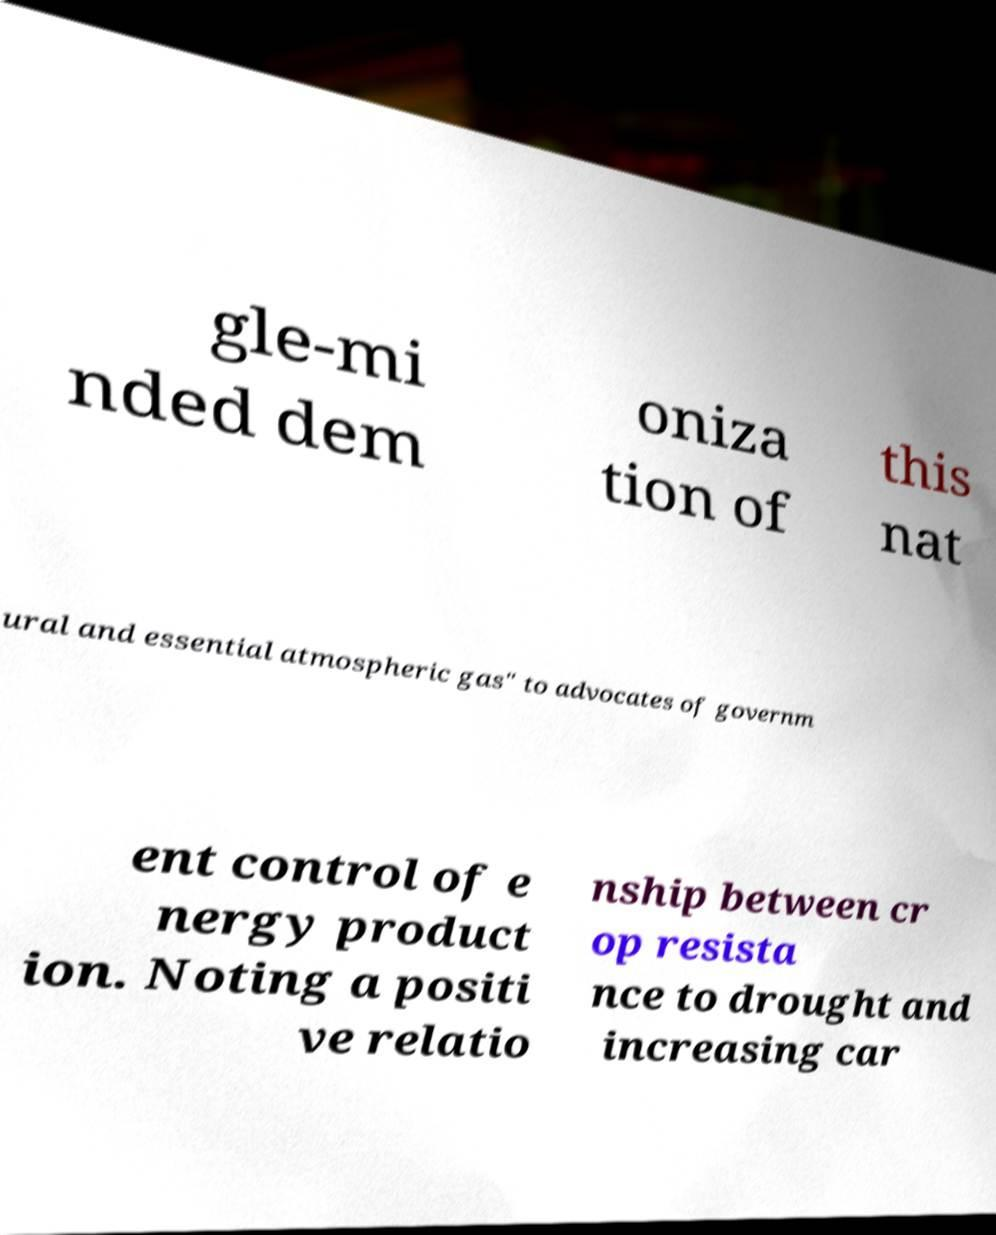Please read and relay the text visible in this image. What does it say? gle-mi nded dem oniza tion of this nat ural and essential atmospheric gas" to advocates of governm ent control of e nergy product ion. Noting a positi ve relatio nship between cr op resista nce to drought and increasing car 